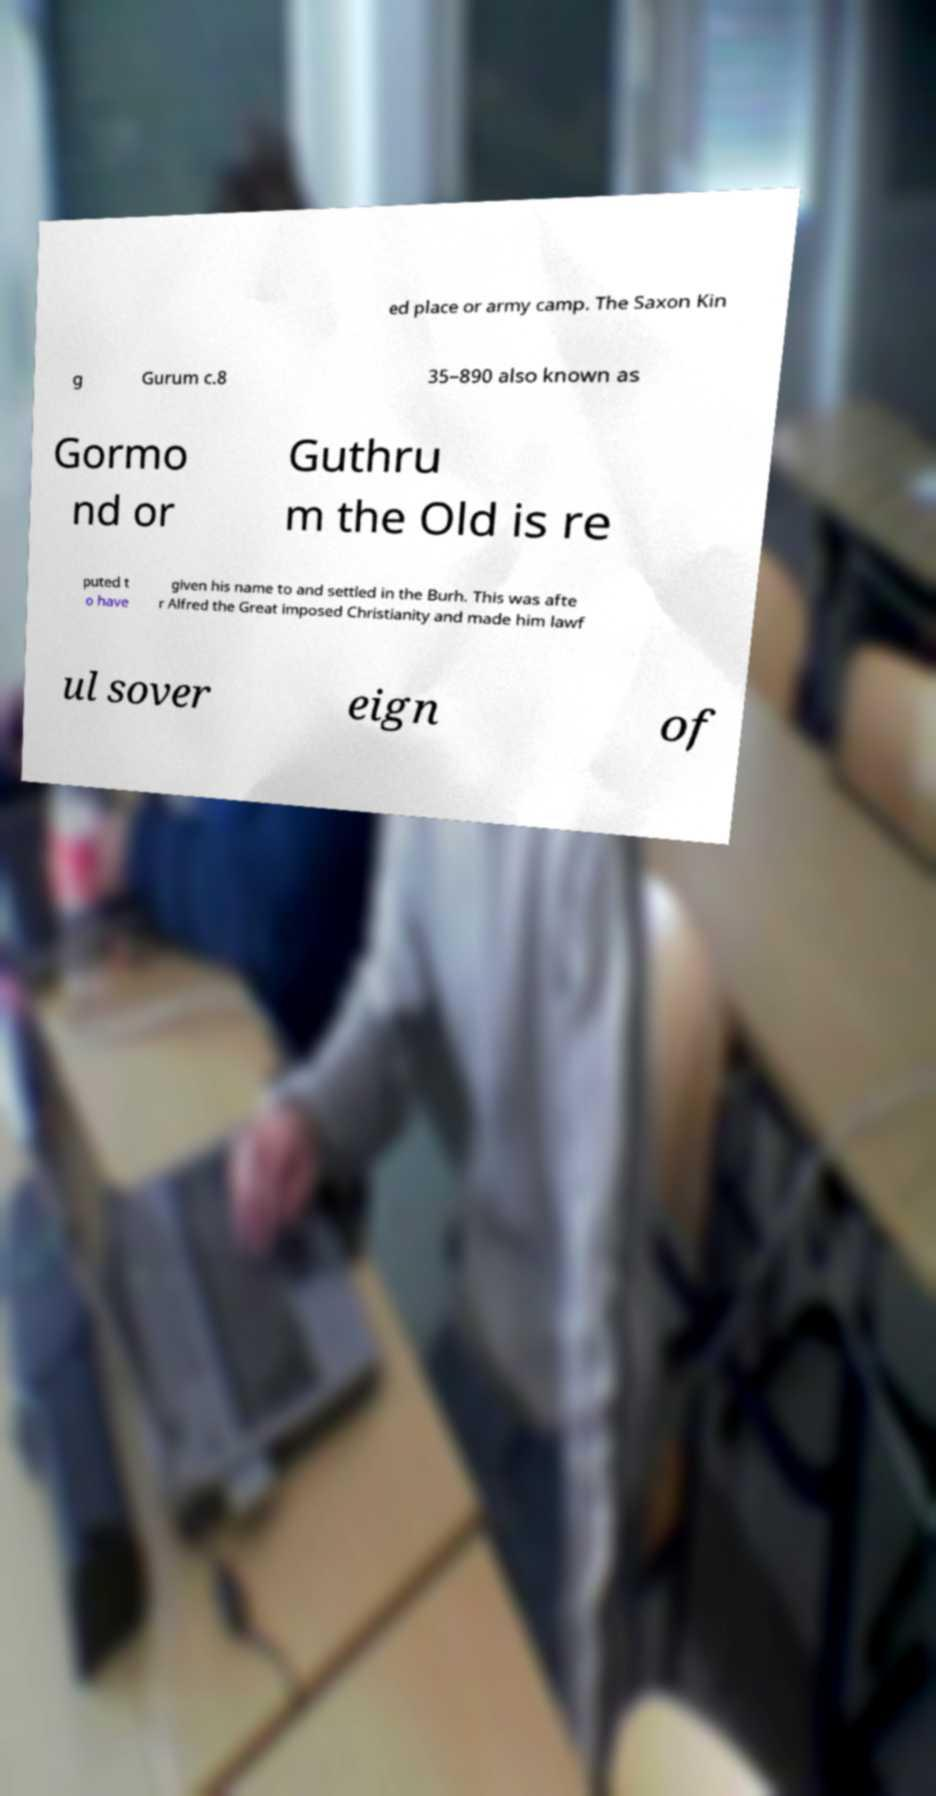There's text embedded in this image that I need extracted. Can you transcribe it verbatim? ed place or army camp. The Saxon Kin g Gurum c.8 35–890 also known as Gormo nd or Guthru m the Old is re puted t o have given his name to and settled in the Burh. This was afte r Alfred the Great imposed Christianity and made him lawf ul sover eign of 